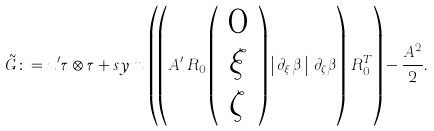<formula> <loc_0><loc_0><loc_500><loc_500>\tilde { G } \colon = u ^ { \prime } \tau \otimes \tau + s y m \, \left ( \left ( A ^ { \prime } \, R _ { 0 } \left ( \begin{array} { c } 0 \\ \xi \\ \zeta \end{array} \right ) \left | \, \partial _ { \xi } \beta \, \right | \, \partial _ { \zeta } \beta \right ) \, R _ { 0 } ^ { T } \right ) - \frac { A ^ { 2 } } { 2 } .</formula> 